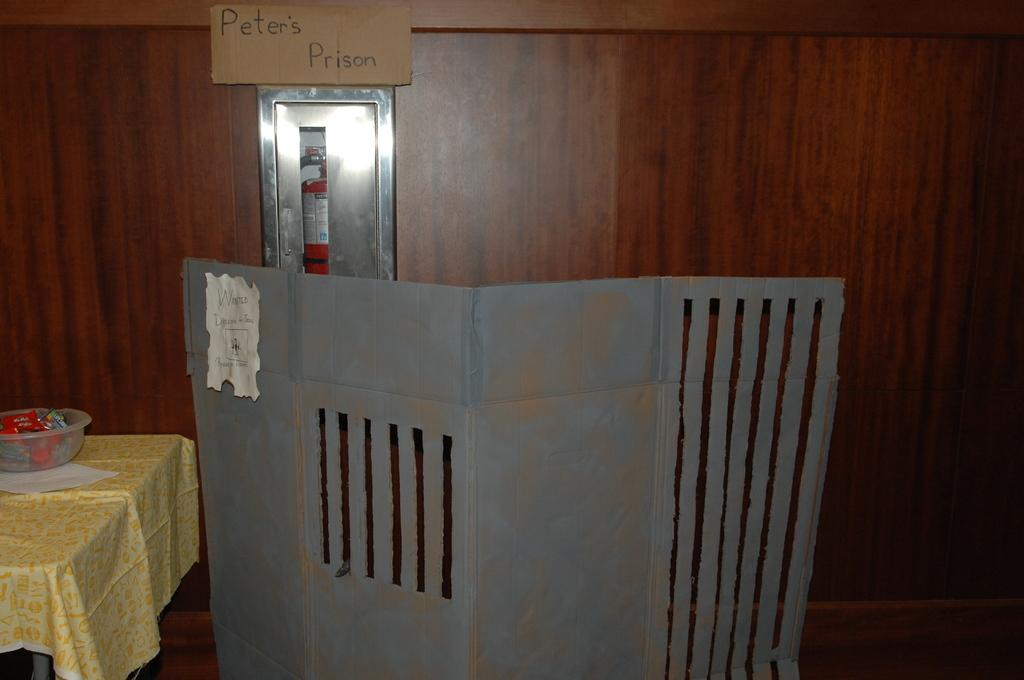<image>
Present a compact description of the photo's key features. a room that has a sign above the fire extinguisher that says 'peter's prison' 